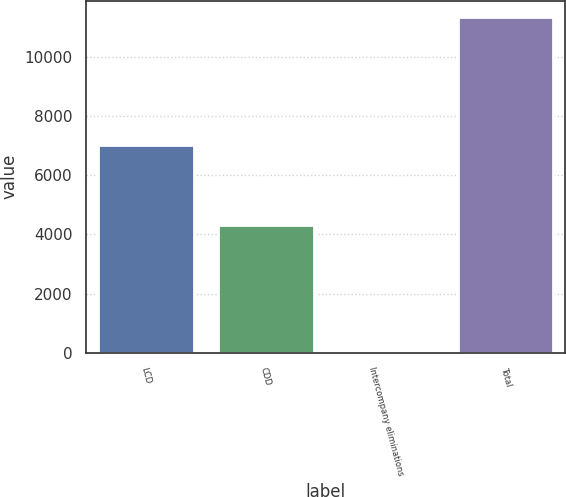<chart> <loc_0><loc_0><loc_500><loc_500><bar_chart><fcel>LCD<fcel>CDD<fcel>Intercompany eliminations<fcel>Total<nl><fcel>7030.8<fcel>4313.1<fcel>10.5<fcel>11333.4<nl></chart> 